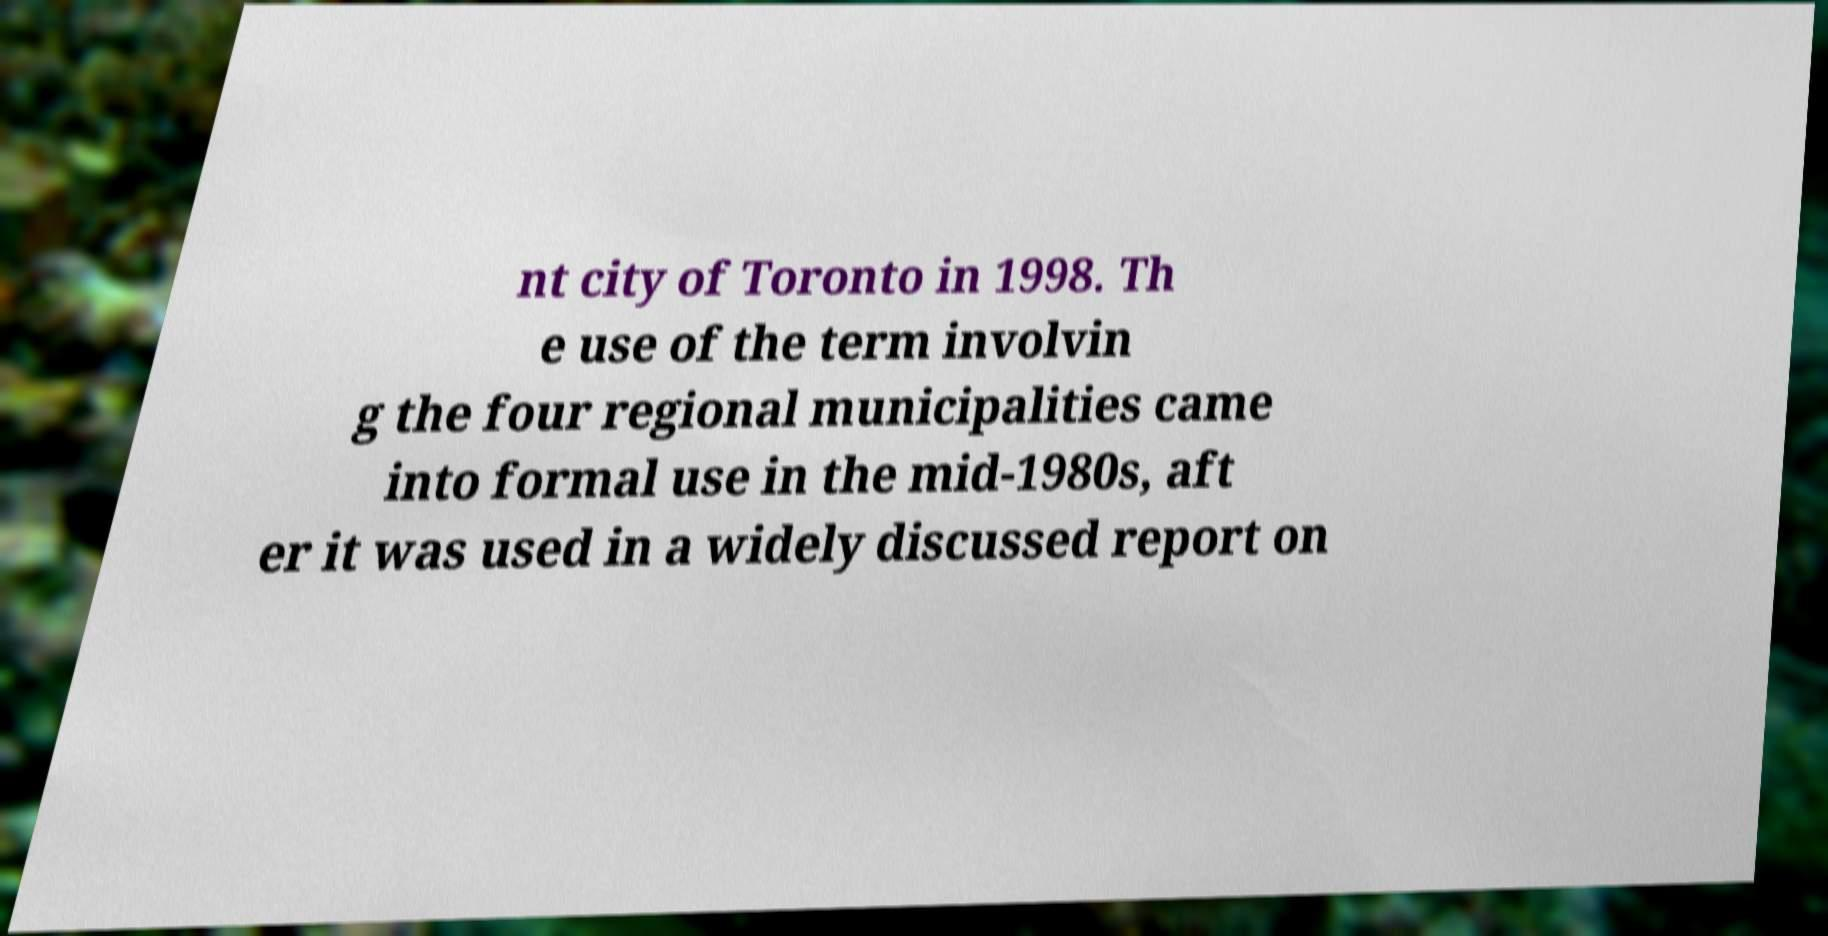Could you extract and type out the text from this image? nt city of Toronto in 1998. Th e use of the term involvin g the four regional municipalities came into formal use in the mid-1980s, aft er it was used in a widely discussed report on 